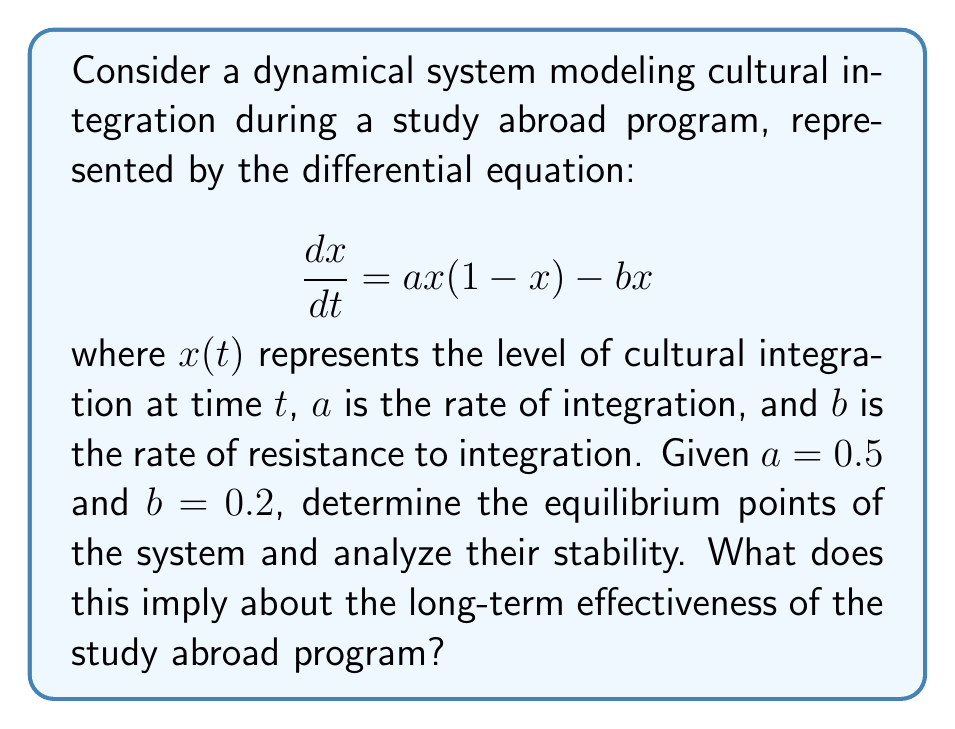Teach me how to tackle this problem. 1) First, we need to find the equilibrium points by setting $\frac{dx}{dt} = 0$:

   $$0 = ax(1-x) - bx$$
   $$0 = 0.5x(1-x) - 0.2x$$
   $$0 = 0.5x - 0.5x^2 - 0.2x$$
   $$0 = 0.3x - 0.5x^2$$
   $$x(0.3 - 0.5x) = 0$$

2) Solving this equation:
   $x = 0$ or $0.3 - 0.5x = 0$
   $x = 0$ or $x = 0.6$

   So, the equilibrium points are $x_1 = 0$ and $x_2 = 0.6$

3) To analyze stability, we need to find $\frac{df}{dx}$ where $f(x) = ax(1-x) - bx$:

   $$\frac{df}{dx} = a(1-x) - ax - b = a - 2ax - b$$

4) Evaluate this at each equilibrium point:

   At $x_1 = 0$: $\frac{df}{dx}|_{x=0} = 0.5 - 0 - 0.2 = 0.3 > 0$
   This means $x_1 = 0$ is an unstable equilibrium.

   At $x_2 = 0.6$: $\frac{df}{dx}|_{x=0.6} = 0.5 - 2(0.5)(0.6) - 0.2 = -0.3 < 0$
   This means $x_2 = 0.6$ is a stable equilibrium.

5) Interpretation: The system will tend towards the stable equilibrium at $x = 0.6$, representing a 60% level of cultural integration in the long term. This suggests that the study abroad program does have a positive effect on cultural integration, but it doesn't lead to complete integration.
Answer: The system has two equilibrium points: $x_1 = 0$ (unstable) and $x_2 = 0.6$ (stable). Long-term behavior tends towards 60% cultural integration. 